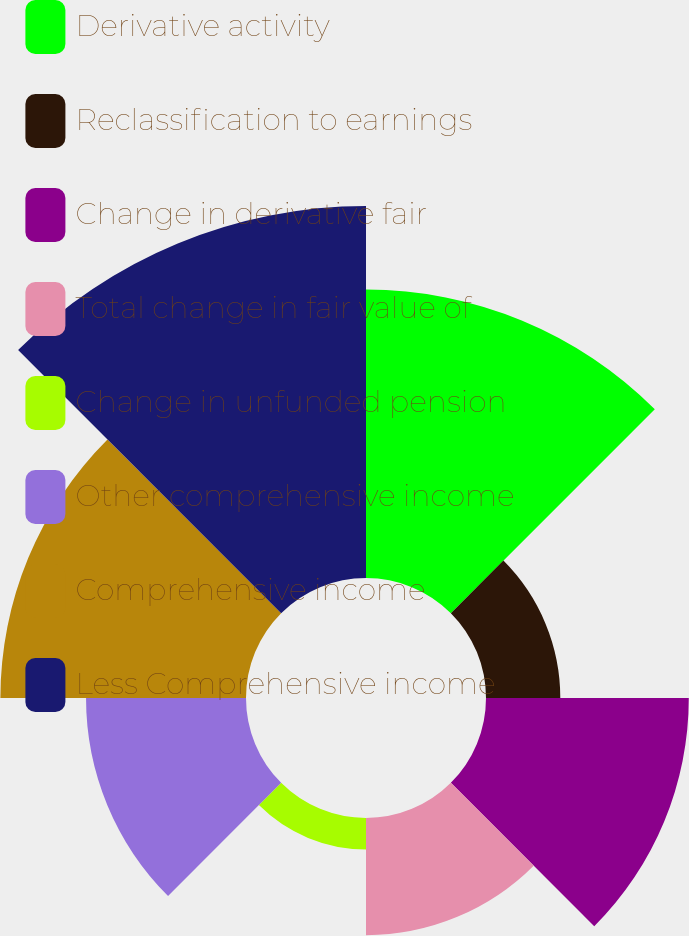<chart> <loc_0><loc_0><loc_500><loc_500><pie_chart><fcel>Derivative activity<fcel>Reclassification to earnings<fcel>Change in derivative fair<fcel>Total change in fair value of<fcel>Change in unfunded pension<fcel>Other comprehensive income<fcel>Comprehensive income<fcel>Less Comprehensive income<nl><fcel>19.33%<fcel>4.98%<fcel>13.59%<fcel>7.85%<fcel>2.11%<fcel>10.72%<fcel>16.46%<fcel>24.93%<nl></chart> 